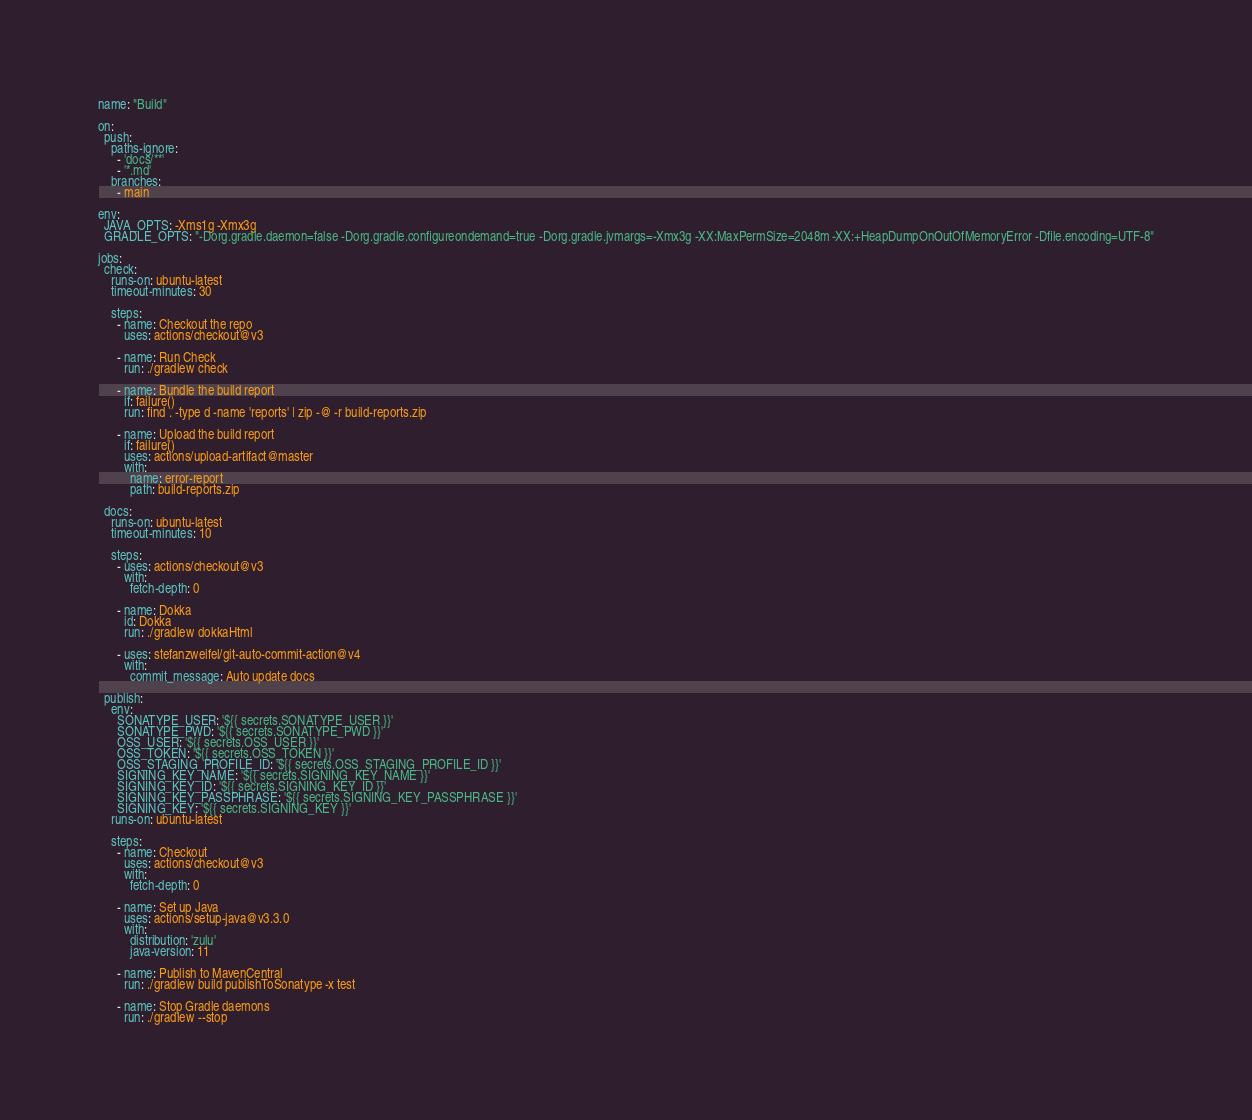Convert code to text. <code><loc_0><loc_0><loc_500><loc_500><_YAML_>name: "Build"

on:
  push:
    paths-ignore:
      - 'docs/**'
      - '*.md'
    branches:
      - main

env:
  JAVA_OPTS: -Xms1g -Xmx3g
  GRADLE_OPTS: "-Dorg.gradle.daemon=false -Dorg.gradle.configureondemand=true -Dorg.gradle.jvmargs=-Xmx3g -XX:MaxPermSize=2048m -XX:+HeapDumpOnOutOfMemoryError -Dfile.encoding=UTF-8"

jobs:
  check:
    runs-on: ubuntu-latest
    timeout-minutes: 30

    steps:
      - name: Checkout the repo
        uses: actions/checkout@v3

      - name: Run Check
        run: ./gradlew check

      - name: Bundle the build report
        if: failure()
        run: find . -type d -name 'reports' | zip -@ -r build-reports.zip

      - name: Upload the build report
        if: failure()
        uses: actions/upload-artifact@master
        with:
          name: error-report
          path: build-reports.zip

  docs:
    runs-on: ubuntu-latest
    timeout-minutes: 10

    steps:
      - uses: actions/checkout@v3
        with:
          fetch-depth: 0

      - name: Dokka
        id: Dokka
        run: ./gradlew dokkaHtml

      - uses: stefanzweifel/git-auto-commit-action@v4
        with:
          commit_message: Auto update docs

  publish:
    env:
      SONATYPE_USER: '${{ secrets.SONATYPE_USER }}'
      SONATYPE_PWD: '${{ secrets.SONATYPE_PWD }}'
      OSS_USER: '${{ secrets.OSS_USER }}'
      OSS_TOKEN: '${{ secrets.OSS_TOKEN }}'
      OSS_STAGING_PROFILE_ID: '${{ secrets.OSS_STAGING_PROFILE_ID }}'
      SIGNING_KEY_NAME: '${{ secrets.SIGNING_KEY_NAME }}'
      SIGNING_KEY_ID: '${{ secrets.SIGNING_KEY_ID }}'
      SIGNING_KEY_PASSPHRASE: '${{ secrets.SIGNING_KEY_PASSPHRASE }}'
      SIGNING_KEY: '${{ secrets.SIGNING_KEY }}'
    runs-on: ubuntu-latest

    steps:
      - name: Checkout
        uses: actions/checkout@v3
        with:
          fetch-depth: 0

      - name: Set up Java
        uses: actions/setup-java@v3.3.0
        with:
          distribution: 'zulu'
          java-version: 11

      - name: Publish to MavenCentral
        run: ./gradlew build publishToSonatype -x test

      - name: Stop Gradle daemons
        run: ./gradlew --stop
</code> 